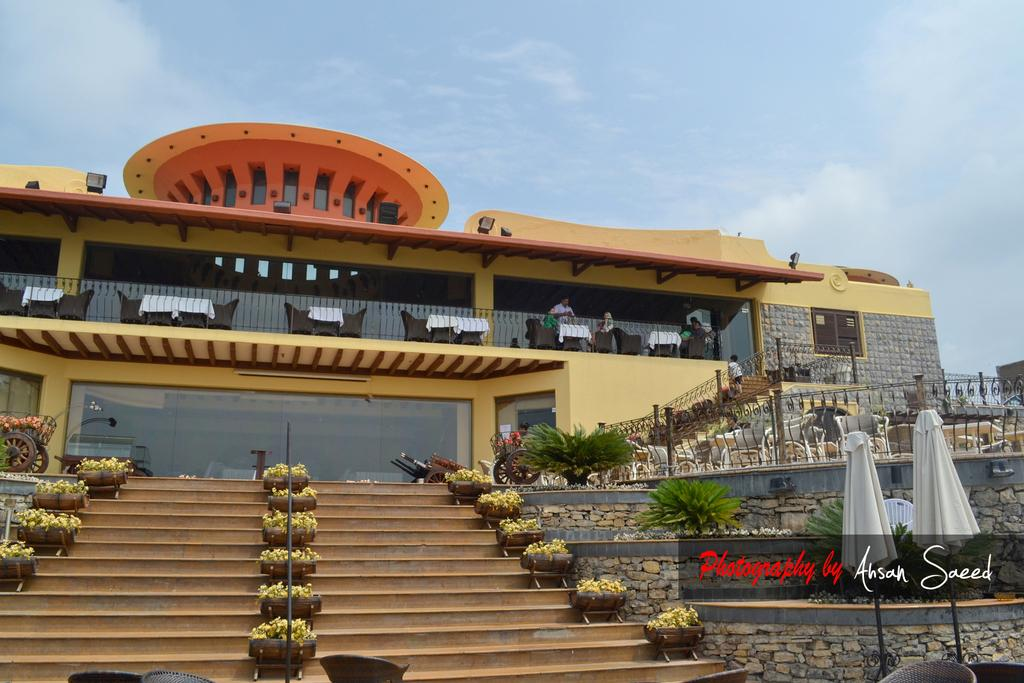What is the main structure in the image? There is a building at the center of the image. What is located in front of the building? There are stairs in front of the building. Are there any decorative elements on the stairs? Yes, flower pots are present on the stairs. What can be seen in the distance in the image? There is a sky visible in the background of the image. What type of produce is being harvested with a fork in the image? There is no produce or fork present in the image. 